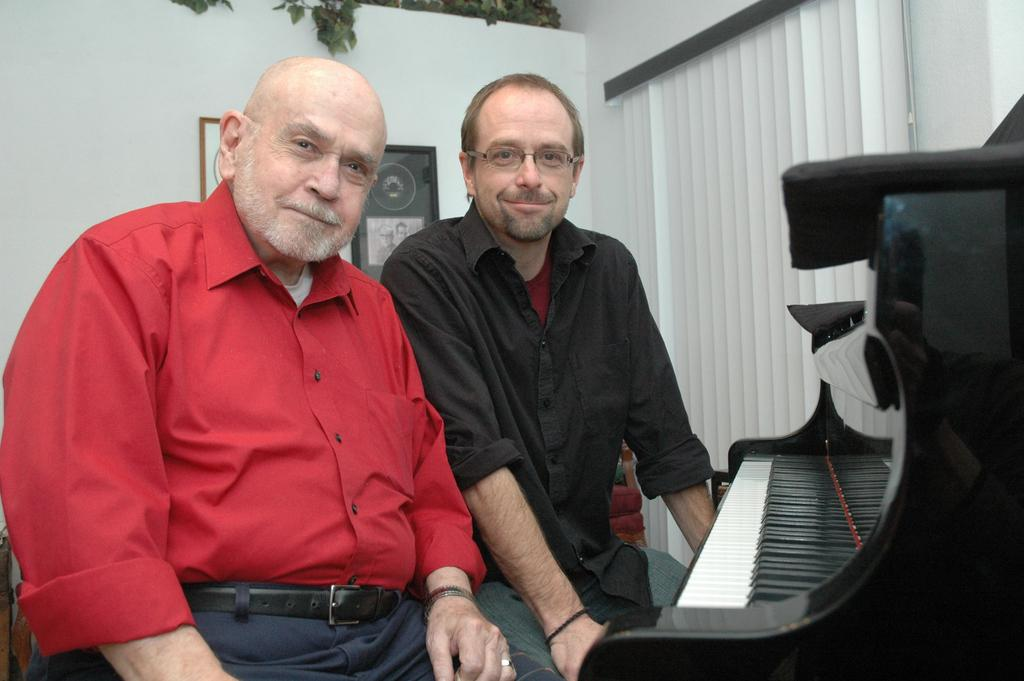How many people are present in the image? There are two persons in the image. Can you describe one of the persons in the image? One of the persons is wearing spectacles. What object can be seen in the image that is typically used for making music? There is a piano in the image. What is visible in the background of the image? There is a wall in the background of the image. What is hanging on the wall in the image? There are frames on the wall. What type of window treatment is present in the image? There is a curtain in the image. How does the person in the image control the chain attached to the wall? There is no chain attached to the wall in the image. 